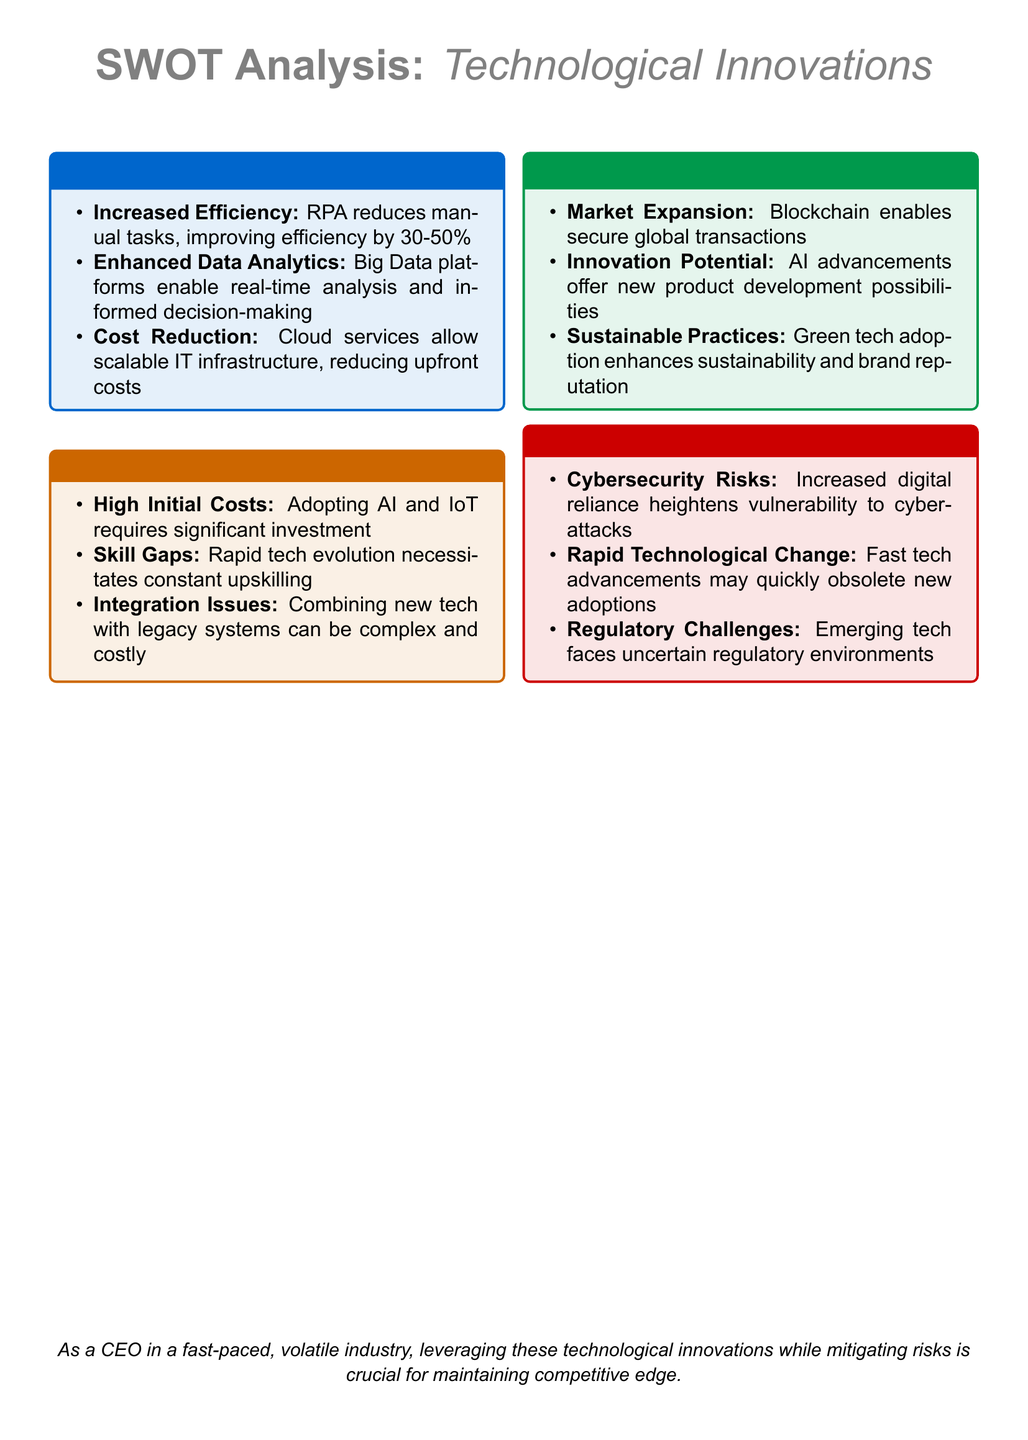what is the efficiency increase range provided by RPA? The efficiency increase range by RPA is specified between 30 to 50 percent.
Answer: 30-50% what is the primary benefit of cloud services mentioned? The main benefit of cloud services highlighted in the document is IT infrastructure cost reduction.
Answer: Cost Reduction name a technology that enhances sustainability. The document indicates that green tech adoption enhances sustainability.
Answer: Green tech what significant risk is associated with increased digital reliance? The document points out that cybersecurity risks heighten with increased digital reliance.
Answer: Cybersecurity Risks what opportunity is related to secure global transactions? Blockchain is identified as an opportunity for enabling secure global transactions.
Answer: Blockchain what is one weakness related to adopting AI and IoT technologies? The document mentions that high initial costs are a weakness of adopting AI and IoT.
Answer: High Initial Costs which innovation offers potential for new product development? AI advancements are described as having innovation potential for new product development.
Answer: AI advancements what challenge is posed by fast technological advancements? The document states that rapid technological change may quickly obsolete new adoptions.
Answer: Rapid Technological Change 